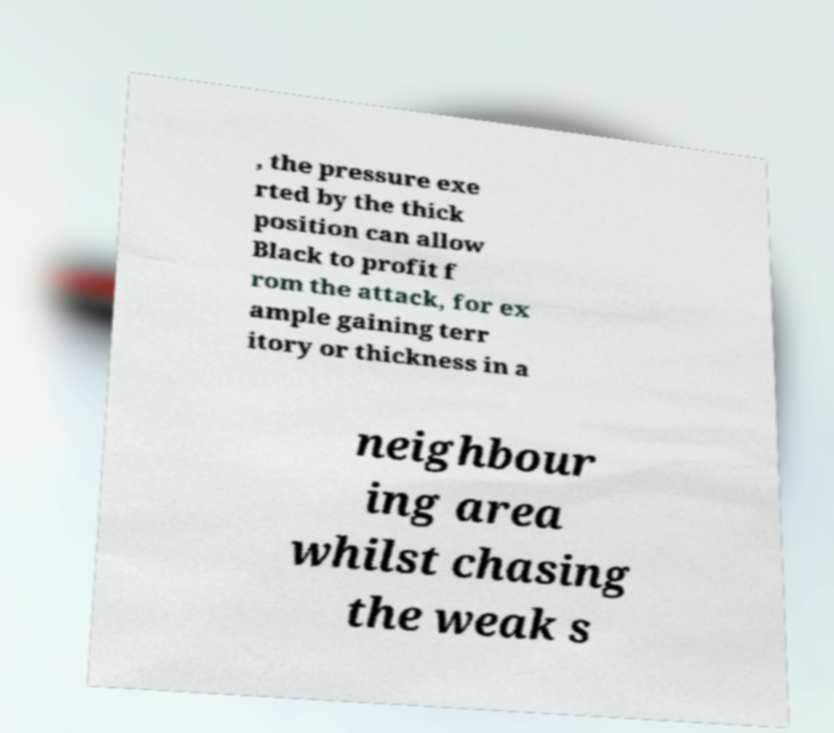Can you read and provide the text displayed in the image?This photo seems to have some interesting text. Can you extract and type it out for me? , the pressure exe rted by the thick position can allow Black to profit f rom the attack, for ex ample gaining terr itory or thickness in a neighbour ing area whilst chasing the weak s 